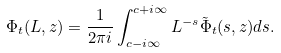Convert formula to latex. <formula><loc_0><loc_0><loc_500><loc_500>\Phi _ { t } ( L , z ) = \frac { 1 } { 2 \pi i } \int _ { c - i \infty } ^ { c + i \infty } L ^ { - s } \tilde { \Phi } _ { t } ( s , z ) d s .</formula> 